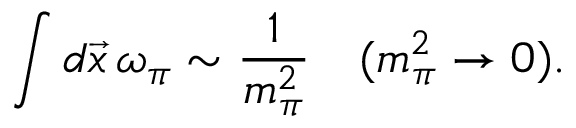<formula> <loc_0><loc_0><loc_500><loc_500>\int d \vec { x } \, \omega _ { \pi } \sim \frac { 1 } m _ { \pi } ^ { 2 } } \quad ( m _ { \pi } ^ { 2 } \rightarrow 0 ) .</formula> 